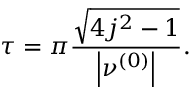<formula> <loc_0><loc_0><loc_500><loc_500>\tau = \pi \frac { \sqrt { 4 j ^ { 2 } - 1 } } { \left | \nu ^ { \left ( 0 \right ) } \right | } .</formula> 